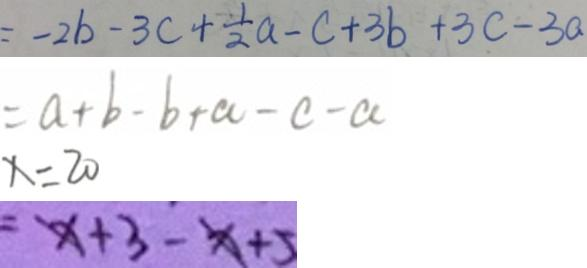<formula> <loc_0><loc_0><loc_500><loc_500>= - 2 b - 3 c + \frac { 1 } { 2 } a - c + 3 b + 3 c - 3 a 
 = a + b - b + a - c - a 
 x = 2 0 
 = x + 3 - x + 5</formula> 